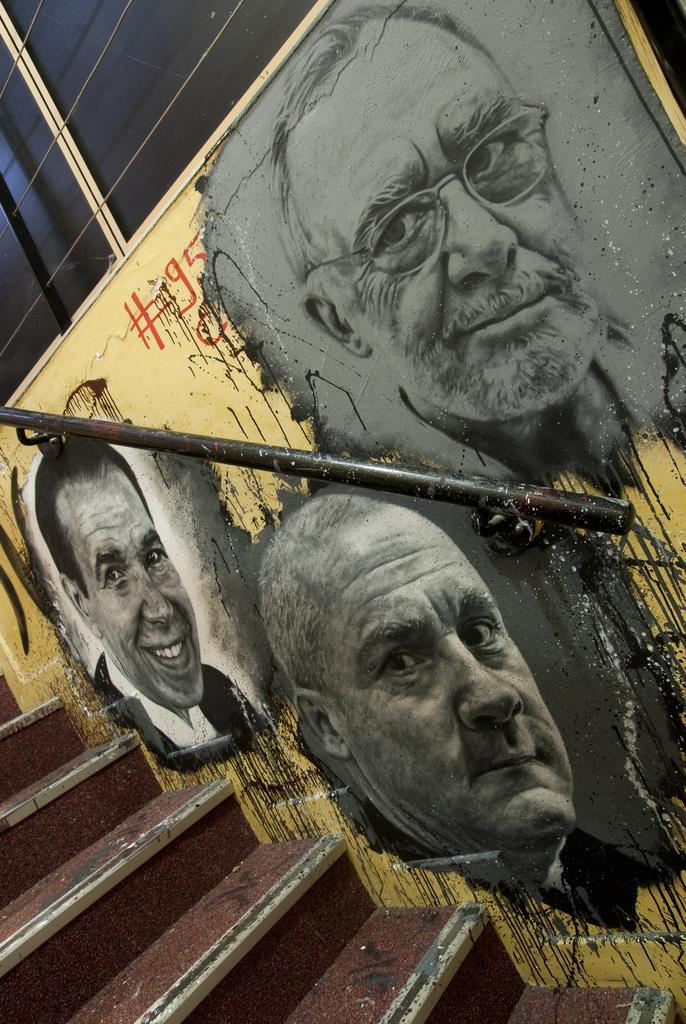Can you describe this image briefly? In this picture there is a painting of the people on the wall and there is a hand rail on the wall and there is a staircase. At the top there is a window. 